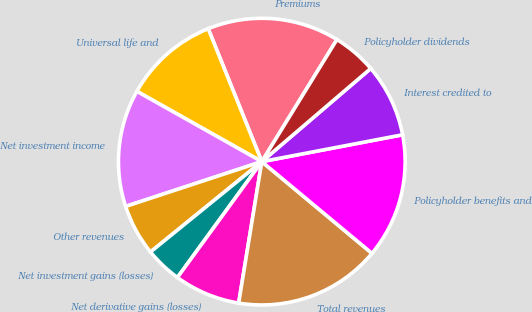Convert chart. <chart><loc_0><loc_0><loc_500><loc_500><pie_chart><fcel>Premiums<fcel>Universal life and<fcel>Net investment income<fcel>Other revenues<fcel>Net investment gains (losses)<fcel>Net derivative gains (losses)<fcel>Total revenues<fcel>Policyholder benefits and<fcel>Interest credited to<fcel>Policyholder dividends<nl><fcel>14.88%<fcel>10.74%<fcel>13.22%<fcel>5.79%<fcel>4.13%<fcel>7.44%<fcel>16.53%<fcel>14.05%<fcel>8.26%<fcel>4.96%<nl></chart> 